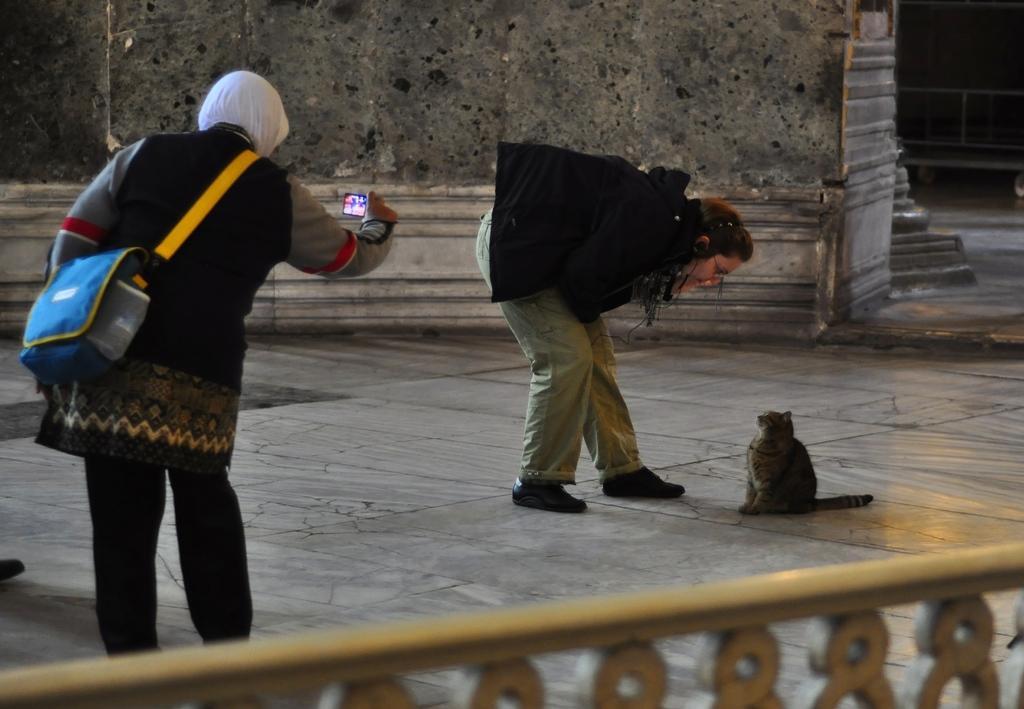Can you describe this image briefly? In this picture a lady is shooting with a camera and in the opposite side a lady is looking at the cat. 